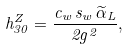Convert formula to latex. <formula><loc_0><loc_0><loc_500><loc_500>h ^ { Z } _ { 3 0 } = \frac { c _ { w } \, s _ { w } \, \widetilde { \alpha } _ { L } } { 2 g ^ { 2 } } ,</formula> 